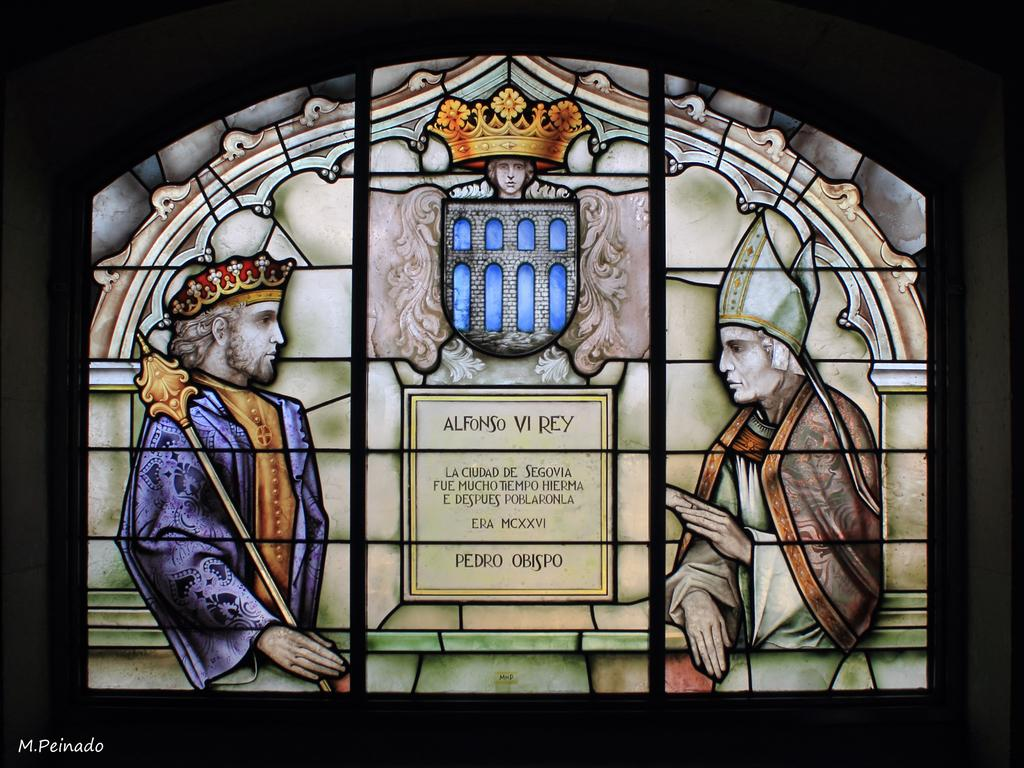<image>
Describe the image concisely. A stained glass window bears the name Pedro Obispo. 